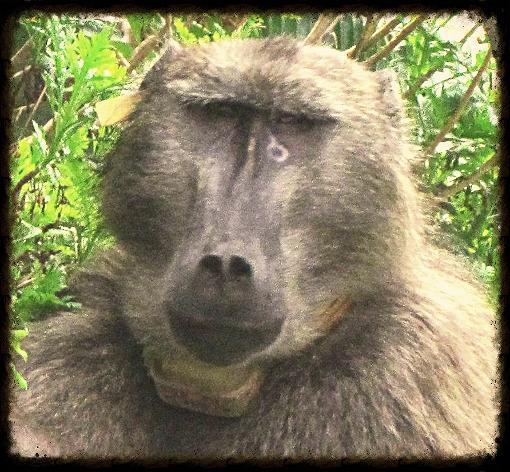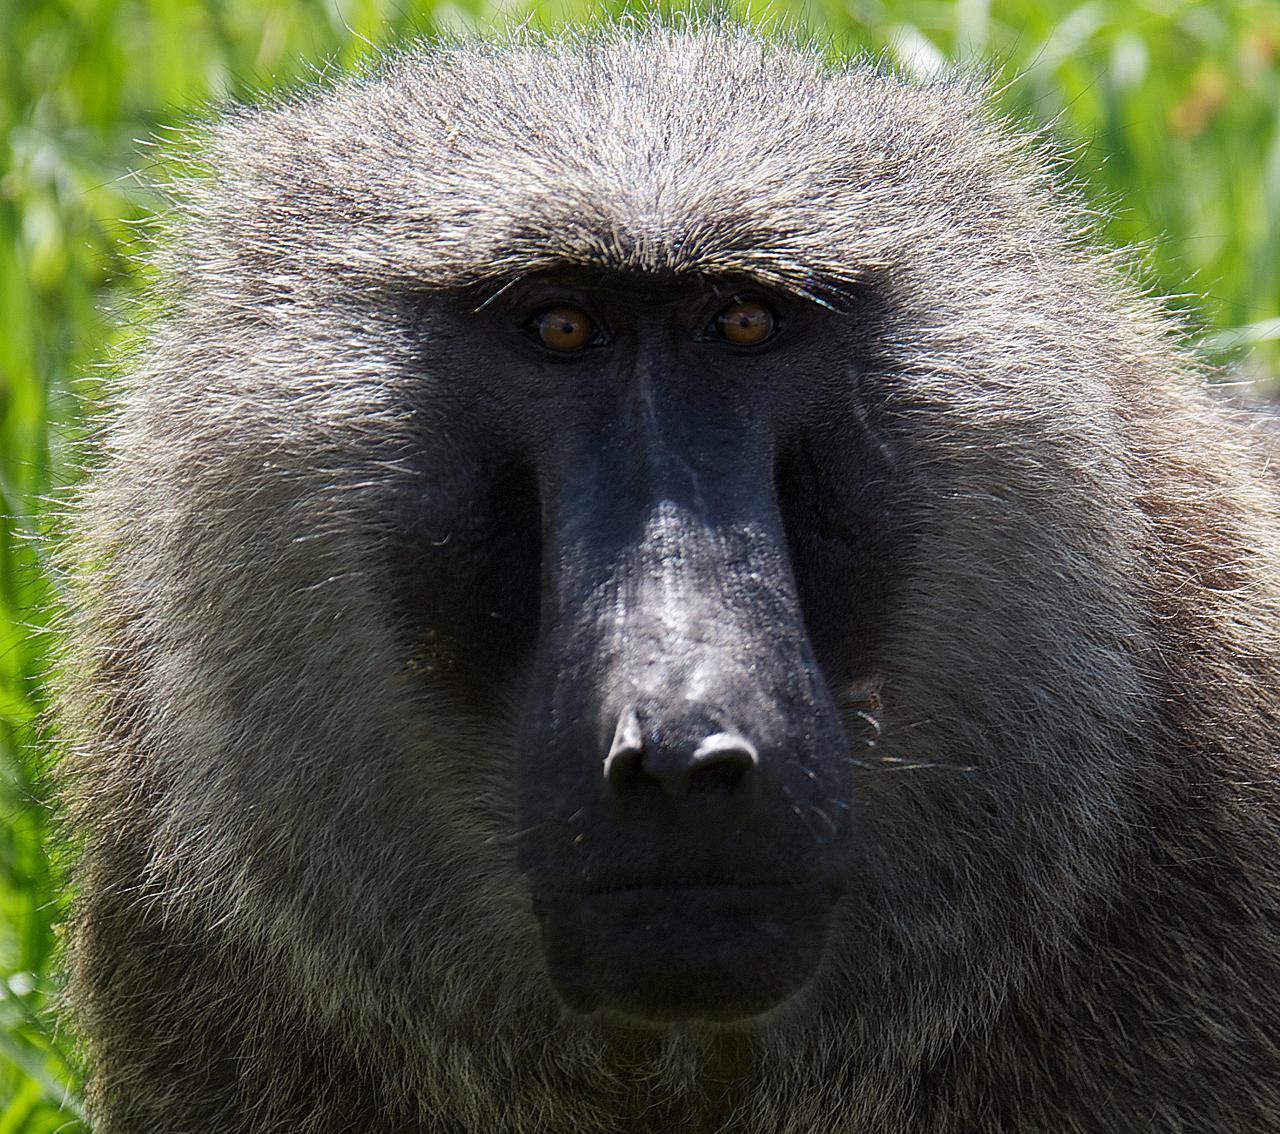The first image is the image on the left, the second image is the image on the right. Given the left and right images, does the statement "There is a single monkey looking in the direction of the camera in the image on the right." hold true? Answer yes or no. Yes. The first image is the image on the left, the second image is the image on the right. Examine the images to the left and right. Is the description "An image shows a juvenile baboon posed with its chest against the chest of an adult baboon." accurate? Answer yes or no. No. 